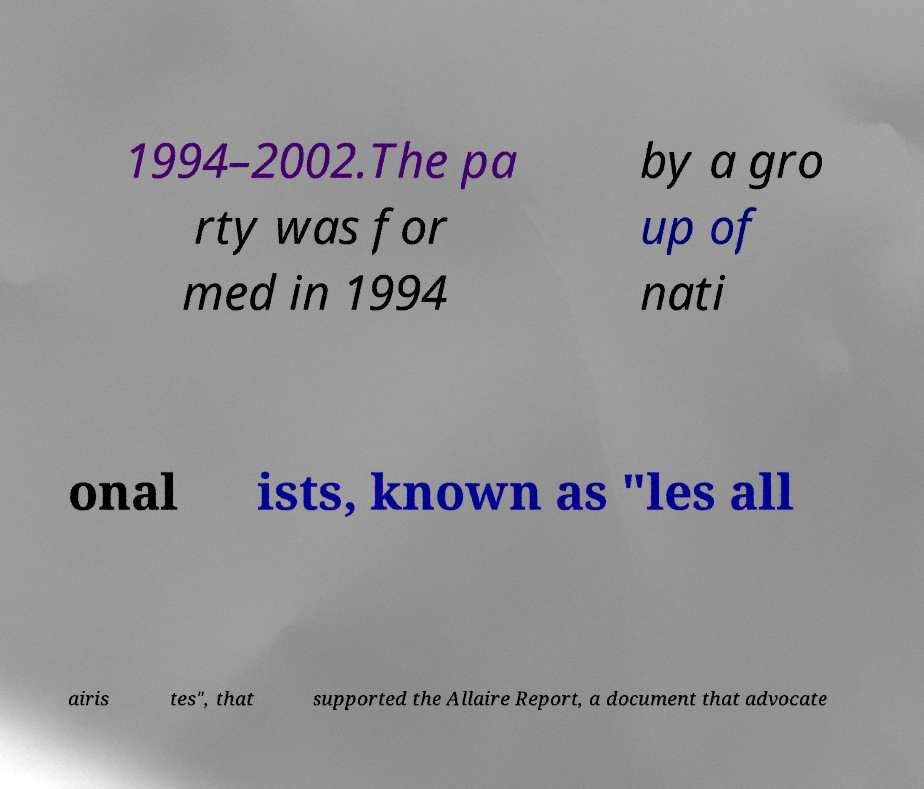Can you read and provide the text displayed in the image?This photo seems to have some interesting text. Can you extract and type it out for me? 1994–2002.The pa rty was for med in 1994 by a gro up of nati onal ists, known as "les all airis tes", that supported the Allaire Report, a document that advocate 